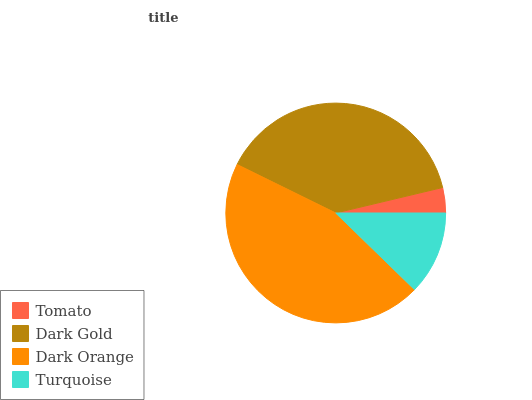Is Tomato the minimum?
Answer yes or no. Yes. Is Dark Orange the maximum?
Answer yes or no. Yes. Is Dark Gold the minimum?
Answer yes or no. No. Is Dark Gold the maximum?
Answer yes or no. No. Is Dark Gold greater than Tomato?
Answer yes or no. Yes. Is Tomato less than Dark Gold?
Answer yes or no. Yes. Is Tomato greater than Dark Gold?
Answer yes or no. No. Is Dark Gold less than Tomato?
Answer yes or no. No. Is Dark Gold the high median?
Answer yes or no. Yes. Is Turquoise the low median?
Answer yes or no. Yes. Is Turquoise the high median?
Answer yes or no. No. Is Dark Gold the low median?
Answer yes or no. No. 